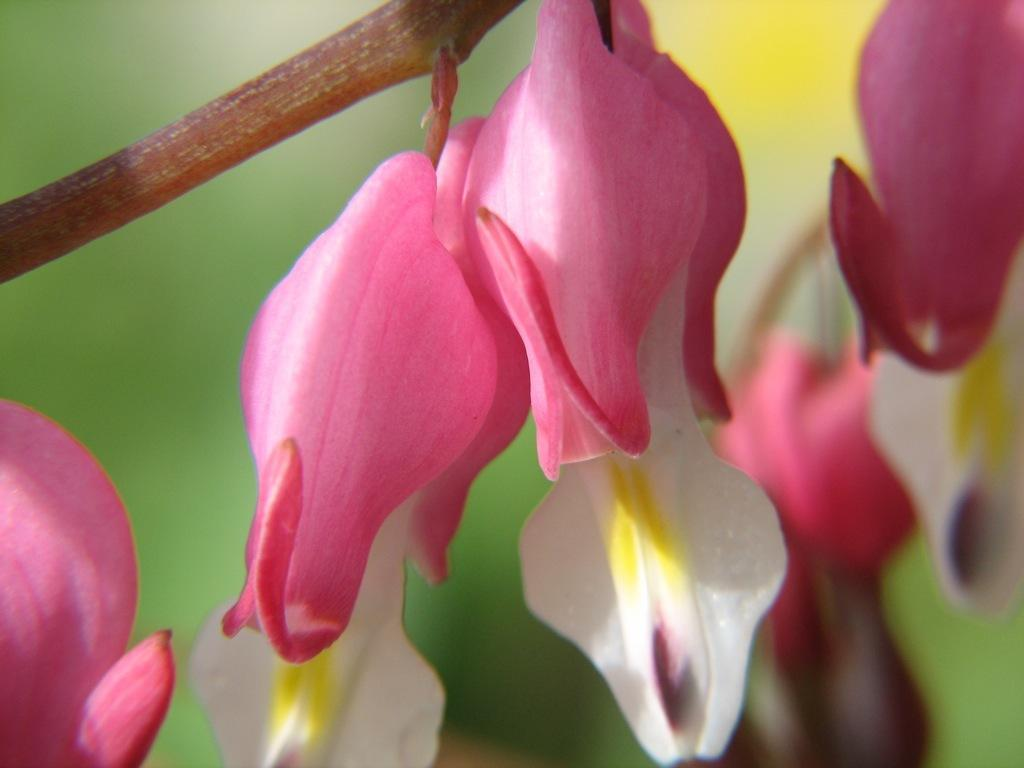What type of plant is visible in the image? There is a plant with a group of flowers on its stem in the image. How many flowers are on the plant? The number of flowers on the plant is not specified in the provided facts. What can be inferred about the plant's growth stage from the image? The image shows flowers on the plant, which suggests that it has reached a stage of blooming. What type of book is the queen reading in the image? There is no queen or book present in the image; it features a plant with flowers on its stem. 